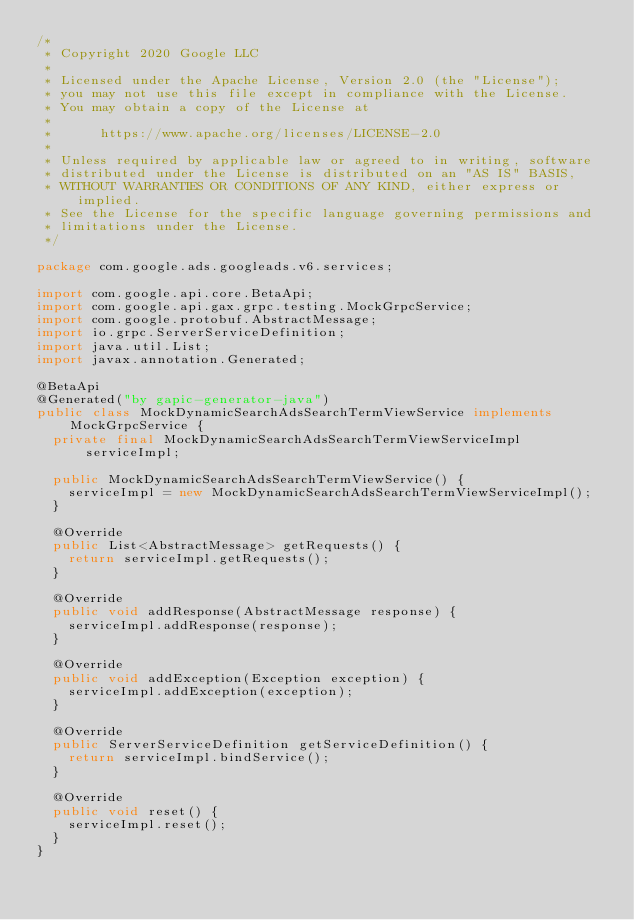<code> <loc_0><loc_0><loc_500><loc_500><_Java_>/*
 * Copyright 2020 Google LLC
 *
 * Licensed under the Apache License, Version 2.0 (the "License");
 * you may not use this file except in compliance with the License.
 * You may obtain a copy of the License at
 *
 *      https://www.apache.org/licenses/LICENSE-2.0
 *
 * Unless required by applicable law or agreed to in writing, software
 * distributed under the License is distributed on an "AS IS" BASIS,
 * WITHOUT WARRANTIES OR CONDITIONS OF ANY KIND, either express or implied.
 * See the License for the specific language governing permissions and
 * limitations under the License.
 */

package com.google.ads.googleads.v6.services;

import com.google.api.core.BetaApi;
import com.google.api.gax.grpc.testing.MockGrpcService;
import com.google.protobuf.AbstractMessage;
import io.grpc.ServerServiceDefinition;
import java.util.List;
import javax.annotation.Generated;

@BetaApi
@Generated("by gapic-generator-java")
public class MockDynamicSearchAdsSearchTermViewService implements MockGrpcService {
  private final MockDynamicSearchAdsSearchTermViewServiceImpl serviceImpl;

  public MockDynamicSearchAdsSearchTermViewService() {
    serviceImpl = new MockDynamicSearchAdsSearchTermViewServiceImpl();
  }

  @Override
  public List<AbstractMessage> getRequests() {
    return serviceImpl.getRequests();
  }

  @Override
  public void addResponse(AbstractMessage response) {
    serviceImpl.addResponse(response);
  }

  @Override
  public void addException(Exception exception) {
    serviceImpl.addException(exception);
  }

  @Override
  public ServerServiceDefinition getServiceDefinition() {
    return serviceImpl.bindService();
  }

  @Override
  public void reset() {
    serviceImpl.reset();
  }
}
</code> 